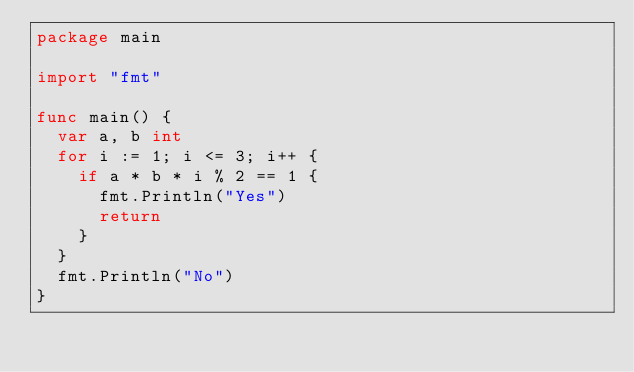Convert code to text. <code><loc_0><loc_0><loc_500><loc_500><_Go_>package main

import "fmt"

func main() {
	var a, b int
	for i := 1; i <= 3; i++ {
		if a * b * i % 2 == 1 {
			fmt.Println("Yes")
			return
		}
	} 
	fmt.Println("No")
}
</code> 